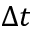Convert formula to latex. <formula><loc_0><loc_0><loc_500><loc_500>\Delta t</formula> 